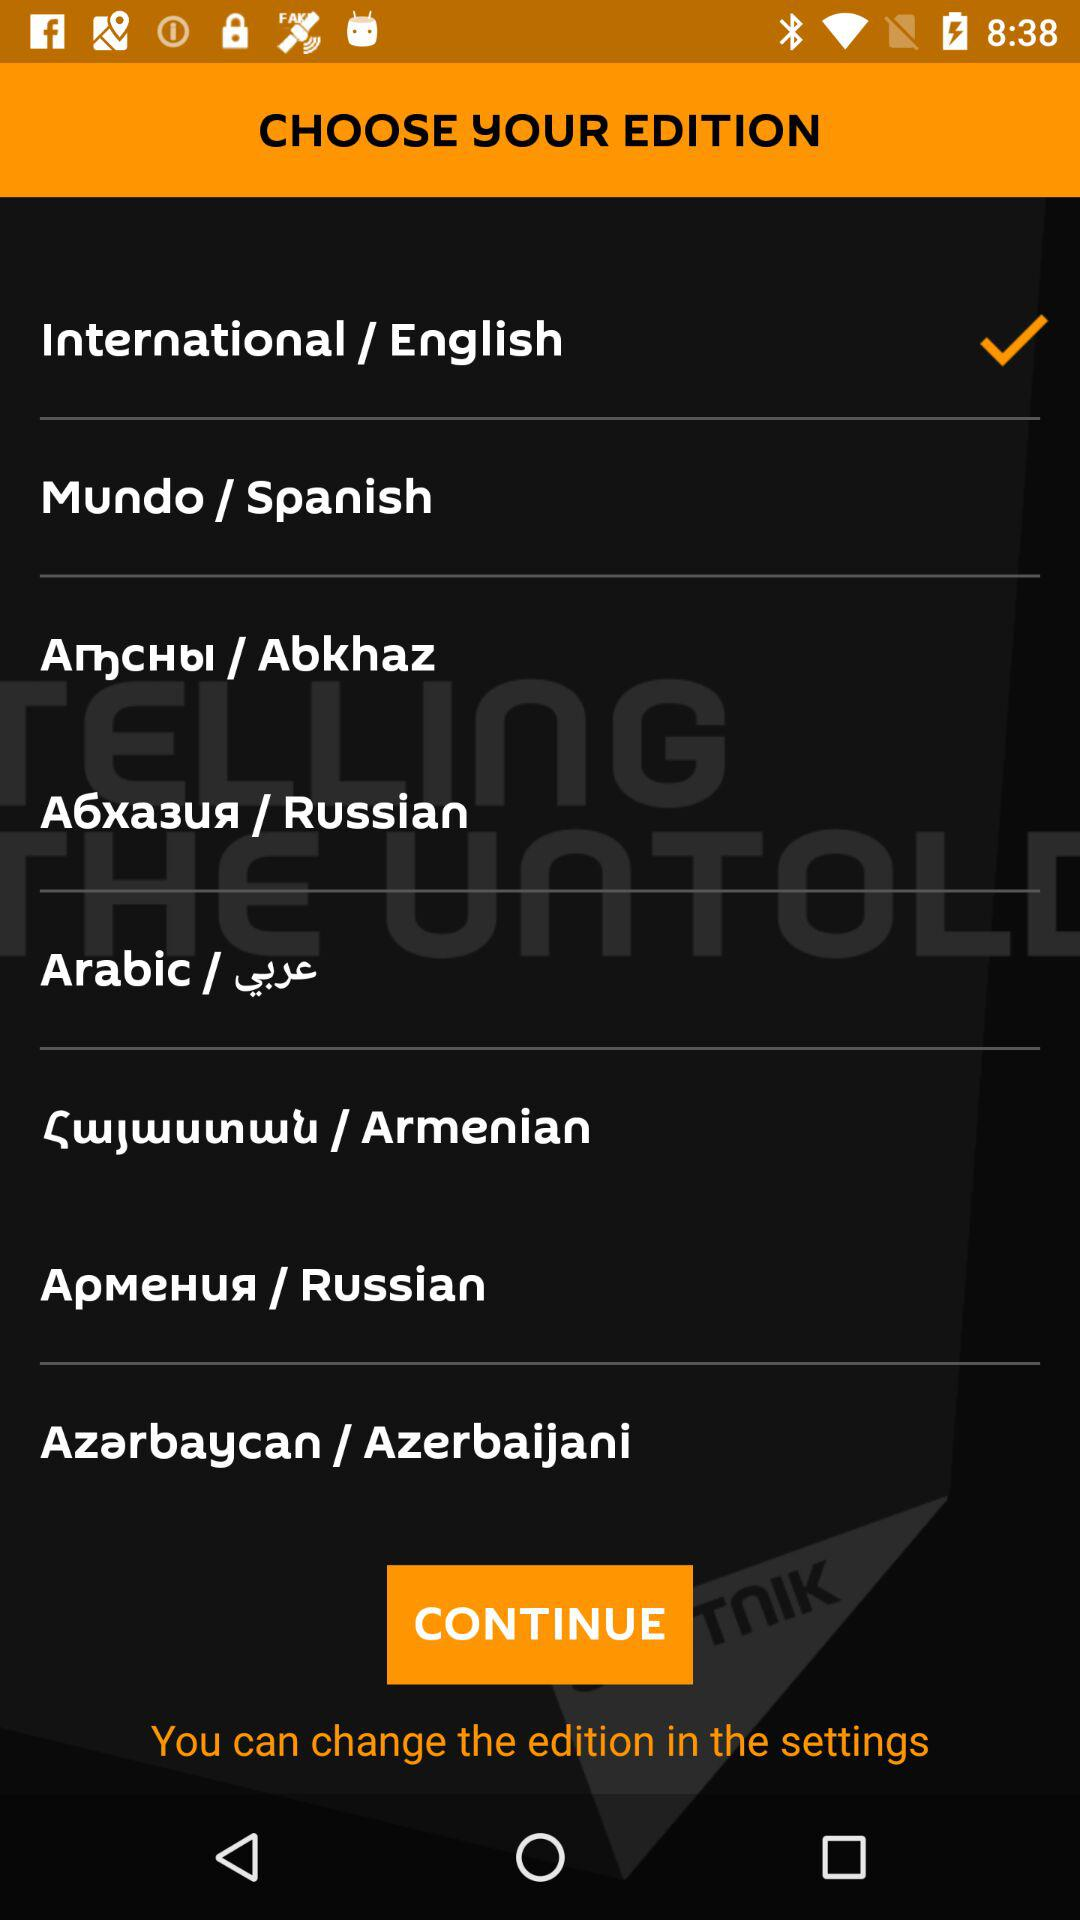What is the selected edition? The selected edition is "International / English". 